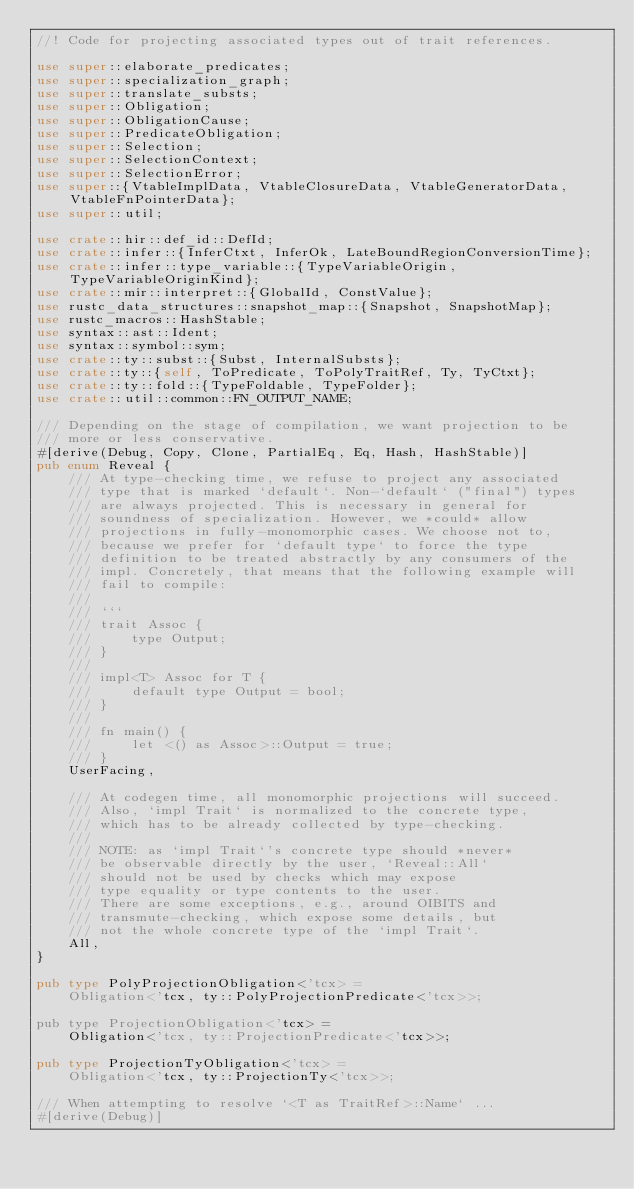Convert code to text. <code><loc_0><loc_0><loc_500><loc_500><_Rust_>//! Code for projecting associated types out of trait references.

use super::elaborate_predicates;
use super::specialization_graph;
use super::translate_substs;
use super::Obligation;
use super::ObligationCause;
use super::PredicateObligation;
use super::Selection;
use super::SelectionContext;
use super::SelectionError;
use super::{VtableImplData, VtableClosureData, VtableGeneratorData, VtableFnPointerData};
use super::util;

use crate::hir::def_id::DefId;
use crate::infer::{InferCtxt, InferOk, LateBoundRegionConversionTime};
use crate::infer::type_variable::{TypeVariableOrigin, TypeVariableOriginKind};
use crate::mir::interpret::{GlobalId, ConstValue};
use rustc_data_structures::snapshot_map::{Snapshot, SnapshotMap};
use rustc_macros::HashStable;
use syntax::ast::Ident;
use syntax::symbol::sym;
use crate::ty::subst::{Subst, InternalSubsts};
use crate::ty::{self, ToPredicate, ToPolyTraitRef, Ty, TyCtxt};
use crate::ty::fold::{TypeFoldable, TypeFolder};
use crate::util::common::FN_OUTPUT_NAME;

/// Depending on the stage of compilation, we want projection to be
/// more or less conservative.
#[derive(Debug, Copy, Clone, PartialEq, Eq, Hash, HashStable)]
pub enum Reveal {
    /// At type-checking time, we refuse to project any associated
    /// type that is marked `default`. Non-`default` ("final") types
    /// are always projected. This is necessary in general for
    /// soundness of specialization. However, we *could* allow
    /// projections in fully-monomorphic cases. We choose not to,
    /// because we prefer for `default type` to force the type
    /// definition to be treated abstractly by any consumers of the
    /// impl. Concretely, that means that the following example will
    /// fail to compile:
    ///
    /// ```
    /// trait Assoc {
    ///     type Output;
    /// }
    ///
    /// impl<T> Assoc for T {
    ///     default type Output = bool;
    /// }
    ///
    /// fn main() {
    ///     let <() as Assoc>::Output = true;
    /// }
    UserFacing,

    /// At codegen time, all monomorphic projections will succeed.
    /// Also, `impl Trait` is normalized to the concrete type,
    /// which has to be already collected by type-checking.
    ///
    /// NOTE: as `impl Trait`'s concrete type should *never*
    /// be observable directly by the user, `Reveal::All`
    /// should not be used by checks which may expose
    /// type equality or type contents to the user.
    /// There are some exceptions, e.g., around OIBITS and
    /// transmute-checking, which expose some details, but
    /// not the whole concrete type of the `impl Trait`.
    All,
}

pub type PolyProjectionObligation<'tcx> =
    Obligation<'tcx, ty::PolyProjectionPredicate<'tcx>>;

pub type ProjectionObligation<'tcx> =
    Obligation<'tcx, ty::ProjectionPredicate<'tcx>>;

pub type ProjectionTyObligation<'tcx> =
    Obligation<'tcx, ty::ProjectionTy<'tcx>>;

/// When attempting to resolve `<T as TraitRef>::Name` ...
#[derive(Debug)]</code> 